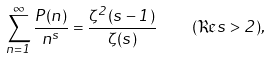<formula> <loc_0><loc_0><loc_500><loc_500>\sum _ { n = 1 } ^ { \infty } \frac { P ( n ) } { n ^ { s } } = \frac { \zeta ^ { 2 } ( s - 1 ) } { \zeta ( s ) } \quad ( \Re s > 2 ) ,</formula> 